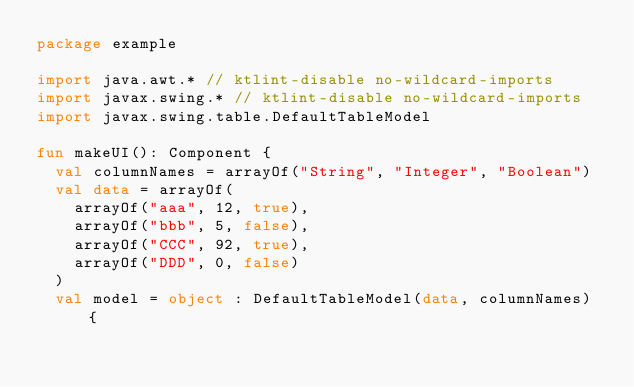<code> <loc_0><loc_0><loc_500><loc_500><_Kotlin_>package example

import java.awt.* // ktlint-disable no-wildcard-imports
import javax.swing.* // ktlint-disable no-wildcard-imports
import javax.swing.table.DefaultTableModel

fun makeUI(): Component {
  val columnNames = arrayOf("String", "Integer", "Boolean")
  val data = arrayOf(
    arrayOf("aaa", 12, true),
    arrayOf("bbb", 5, false),
    arrayOf("CCC", 92, true),
    arrayOf("DDD", 0, false)
  )
  val model = object : DefaultTableModel(data, columnNames) {</code> 